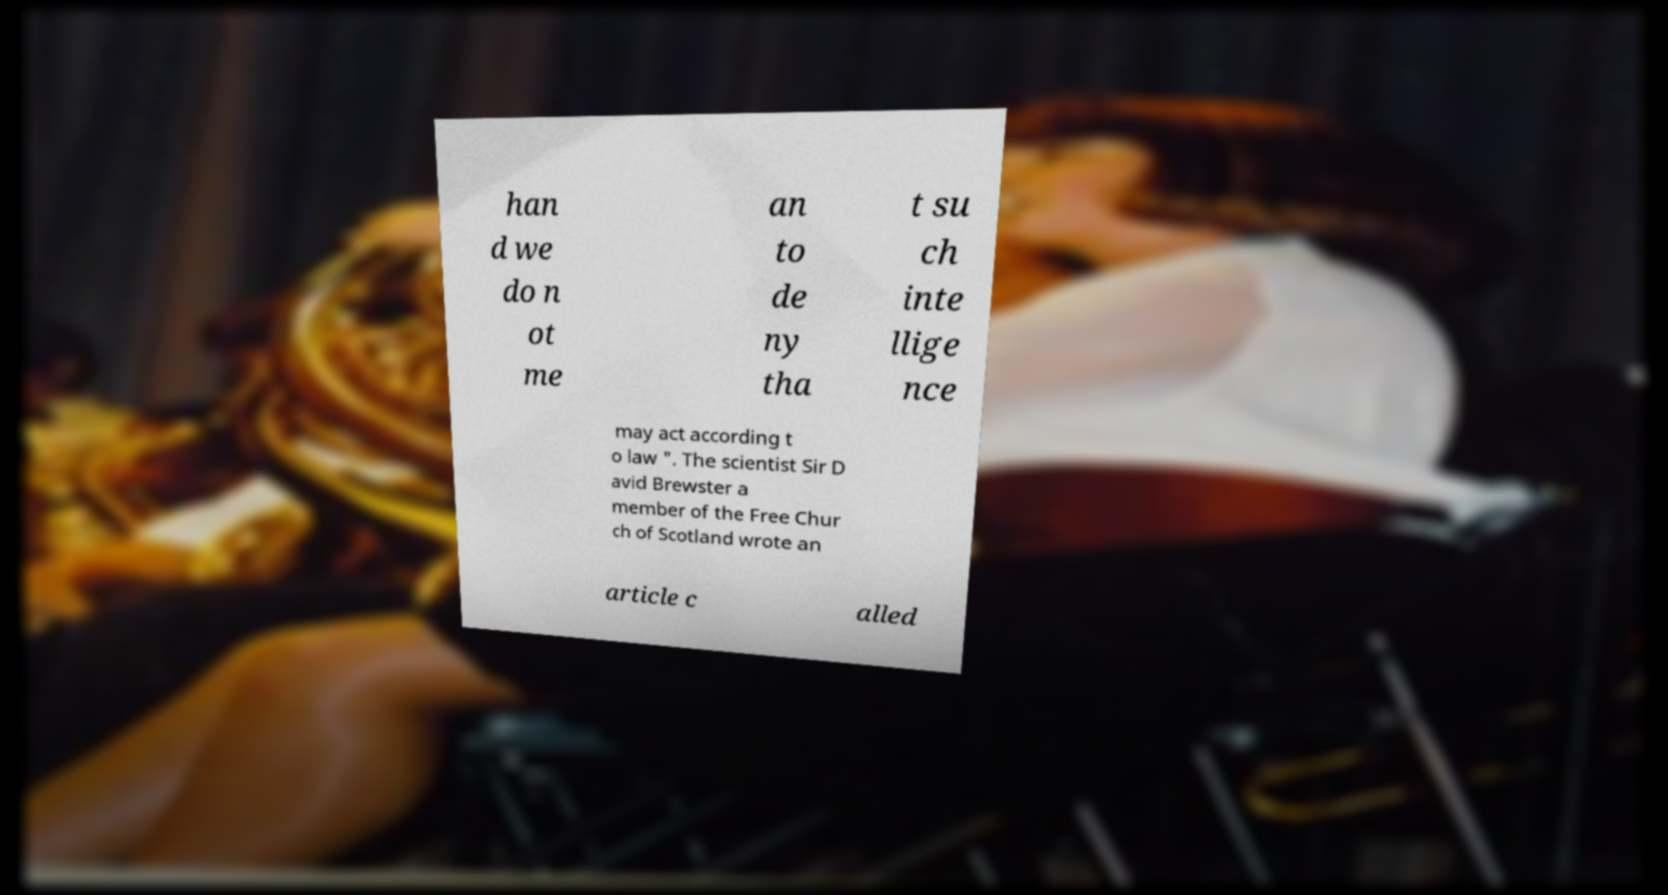Please read and relay the text visible in this image. What does it say? han d we do n ot me an to de ny tha t su ch inte llige nce may act according t o law ". The scientist Sir D avid Brewster a member of the Free Chur ch of Scotland wrote an article c alled 